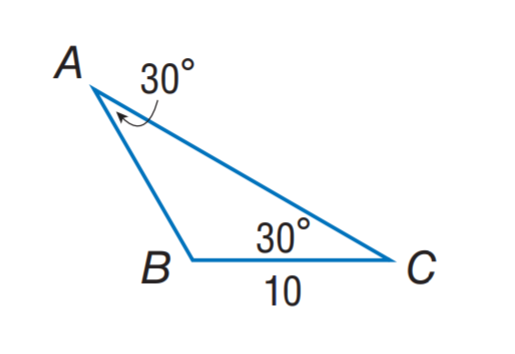Answer the mathemtical geometry problem and directly provide the correct option letter.
Question: Find A B.
Choices: A: 5 B: 10 C: 20 D: 30 B 